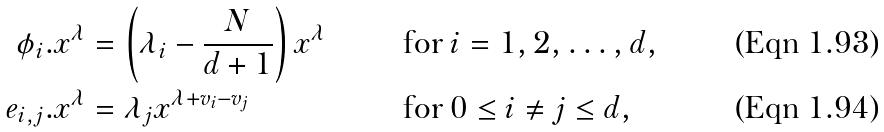Convert formula to latex. <formula><loc_0><loc_0><loc_500><loc_500>\phi _ { i } . x ^ { \lambda } & = \left ( \lambda _ { i } - \frac { N } { d + 1 } \right ) x ^ { \lambda } & & \text {for } i = 1 , 2 , \dots , d , \\ e _ { i , j } . x ^ { \lambda } & = \lambda _ { j } x ^ { \lambda + v _ { i } - v _ { j } } & & \text {for } 0 \leq i \neq j \leq d ,</formula> 